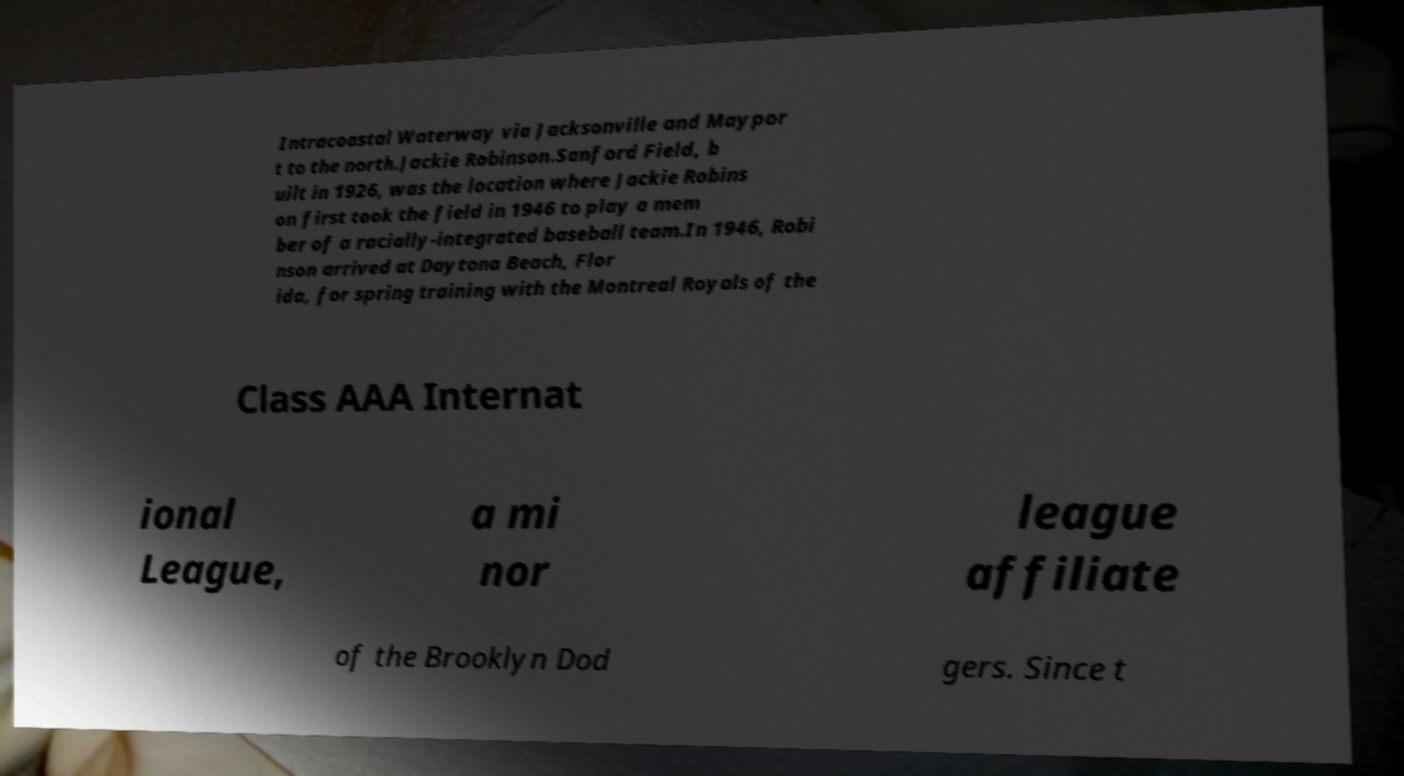For documentation purposes, I need the text within this image transcribed. Could you provide that? Intracoastal Waterway via Jacksonville and Maypor t to the north.Jackie Robinson.Sanford Field, b uilt in 1926, was the location where Jackie Robins on first took the field in 1946 to play a mem ber of a racially-integrated baseball team.In 1946, Robi nson arrived at Daytona Beach, Flor ida, for spring training with the Montreal Royals of the Class AAA Internat ional League, a mi nor league affiliate of the Brooklyn Dod gers. Since t 